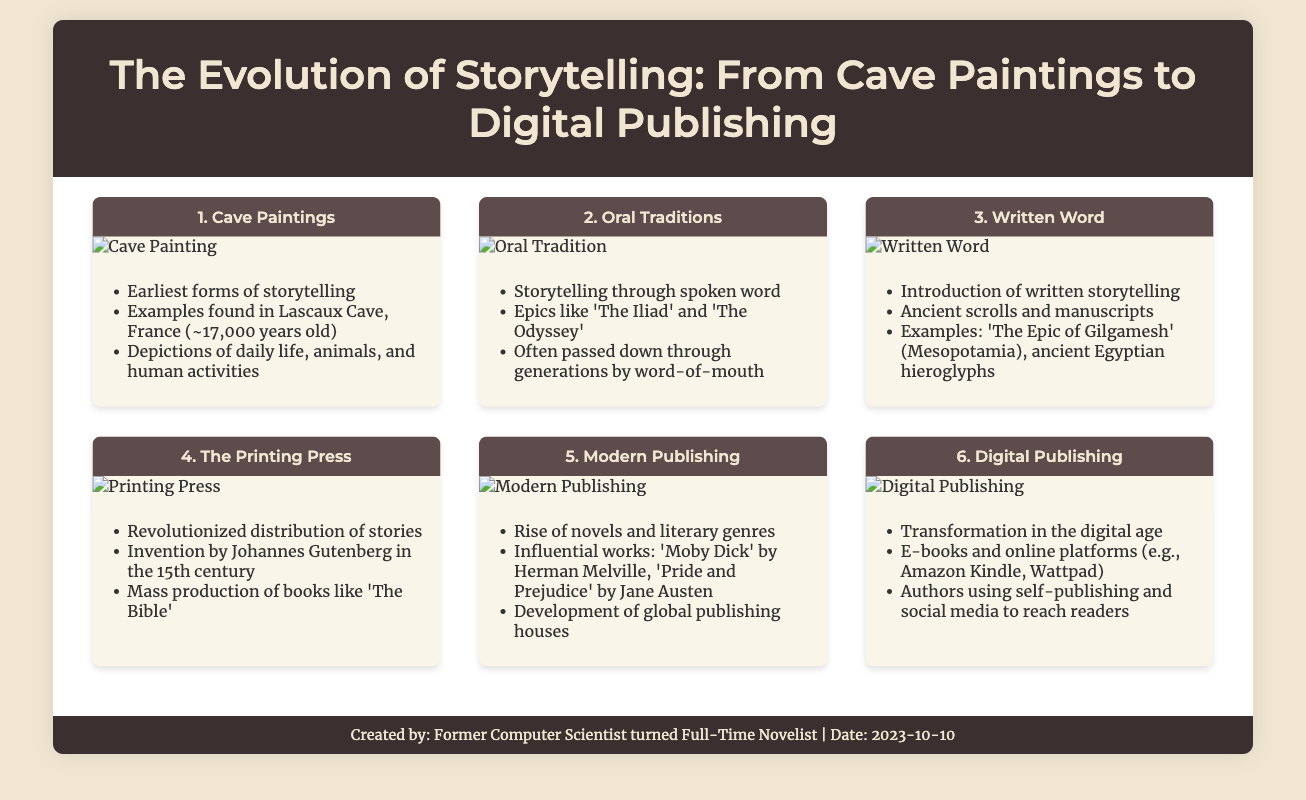What is the earliest form of storytelling? The earliest form of storytelling mentioned in the document is Cave Paintings.
Answer: Cave Paintings How old are the cave paintings found in Lascaux Cave, France? The document states the cave paintings are approximately 17,000 years old.
Answer: 17,000 years Who invented the printing press? The document attributes the invention of the printing press to Johannes Gutenberg.
Answer: Johannes Gutenberg What is one example of an influential work listed under Modern Publishing? 'Pride and Prejudice' by Jane Austen is given as an example of an influential work in Modern Publishing.
Answer: Pride and Prejudice What transformation occurred in storytelling during the digital age? The document notes the transformation in storytelling involved e-books and online platforms.
Answer: E-books and online platforms What method is mentioned for authors to reach readers today? The document states that authors now use self-publishing and social media to reach readers.
Answer: Self-publishing and social media What century was the printing press invented? The document indicates that the printing press was invented in the 15th century.
Answer: 15th century Which storytelling method emphasizes spoken word? The document refers to Oral Traditions as the storytelling method that emphasizes spoken word.
Answer: Oral Traditions 